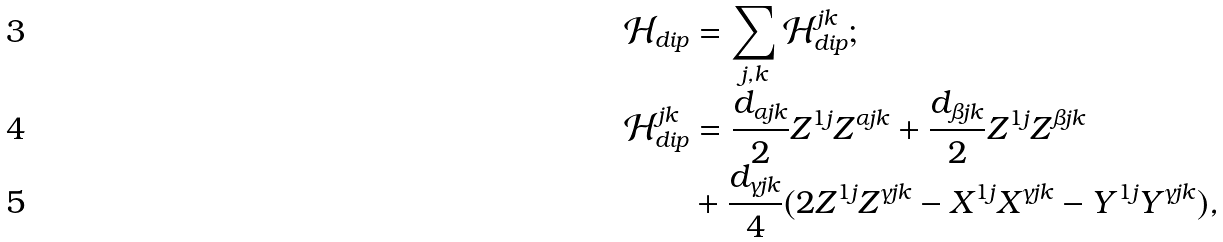Convert formula to latex. <formula><loc_0><loc_0><loc_500><loc_500>\mathcal { H } _ { d i p } & = \sum _ { j , k } \mathcal { H } ^ { j k } _ { d i p } ; \\ \mathcal { H } ^ { j k } _ { d i p } & = \frac { d _ { \alpha j k } } { 2 } Z ^ { 1 j } Z ^ { \alpha j k } + \frac { d _ { \beta j k } } { 2 } Z ^ { 1 j } Z ^ { \beta j k } \\ & + \frac { d _ { \gamma j k } } { 4 } ( 2 Z ^ { 1 j } Z ^ { \gamma j k } - X ^ { 1 j } X ^ { \gamma j k } - Y ^ { 1 j } Y ^ { \gamma j k } ) ,</formula> 